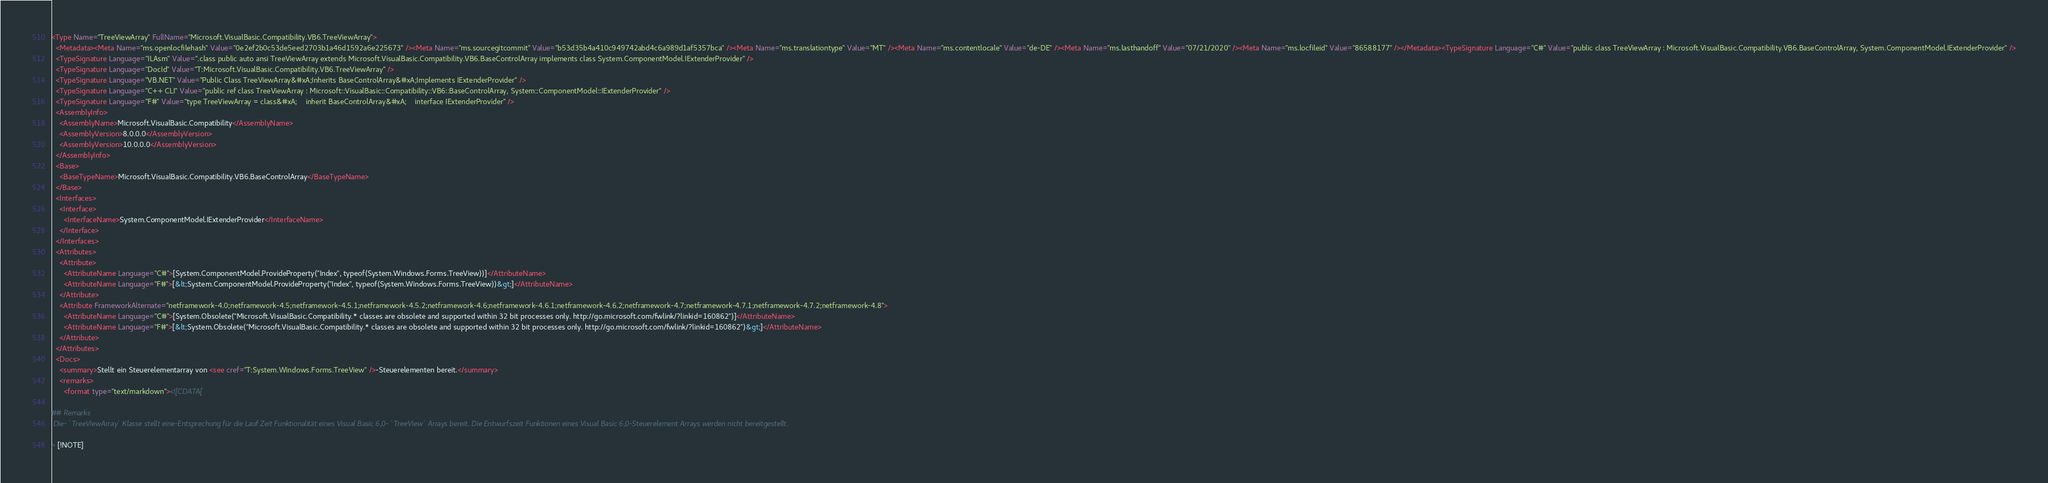Convert code to text. <code><loc_0><loc_0><loc_500><loc_500><_XML_><Type Name="TreeViewArray" FullName="Microsoft.VisualBasic.Compatibility.VB6.TreeViewArray">
  <Metadata><Meta Name="ms.openlocfilehash" Value="0e2ef2b0c53de5eed2703b1a46d1592a6e225673" /><Meta Name="ms.sourcegitcommit" Value="b53d35b4a410c949742abd4c6a989d1af5357bca" /><Meta Name="ms.translationtype" Value="MT" /><Meta Name="ms.contentlocale" Value="de-DE" /><Meta Name="ms.lasthandoff" Value="07/21/2020" /><Meta Name="ms.locfileid" Value="86588177" /></Metadata><TypeSignature Language="C#" Value="public class TreeViewArray : Microsoft.VisualBasic.Compatibility.VB6.BaseControlArray, System.ComponentModel.IExtenderProvider" />
  <TypeSignature Language="ILAsm" Value=".class public auto ansi TreeViewArray extends Microsoft.VisualBasic.Compatibility.VB6.BaseControlArray implements class System.ComponentModel.IExtenderProvider" />
  <TypeSignature Language="DocId" Value="T:Microsoft.VisualBasic.Compatibility.VB6.TreeViewArray" />
  <TypeSignature Language="VB.NET" Value="Public Class TreeViewArray&#xA;Inherits BaseControlArray&#xA;Implements IExtenderProvider" />
  <TypeSignature Language="C++ CLI" Value="public ref class TreeViewArray : Microsoft::VisualBasic::Compatibility::VB6::BaseControlArray, System::ComponentModel::IExtenderProvider" />
  <TypeSignature Language="F#" Value="type TreeViewArray = class&#xA;    inherit BaseControlArray&#xA;    interface IExtenderProvider" />
  <AssemblyInfo>
    <AssemblyName>Microsoft.VisualBasic.Compatibility</AssemblyName>
    <AssemblyVersion>8.0.0.0</AssemblyVersion>
    <AssemblyVersion>10.0.0.0</AssemblyVersion>
  </AssemblyInfo>
  <Base>
    <BaseTypeName>Microsoft.VisualBasic.Compatibility.VB6.BaseControlArray</BaseTypeName>
  </Base>
  <Interfaces>
    <Interface>
      <InterfaceName>System.ComponentModel.IExtenderProvider</InterfaceName>
    </Interface>
  </Interfaces>
  <Attributes>
    <Attribute>
      <AttributeName Language="C#">[System.ComponentModel.ProvideProperty("Index", typeof(System.Windows.Forms.TreeView))]</AttributeName>
      <AttributeName Language="F#">[&lt;System.ComponentModel.ProvideProperty("Index", typeof(System.Windows.Forms.TreeView))&gt;]</AttributeName>
    </Attribute>
    <Attribute FrameworkAlternate="netframework-4.0;netframework-4.5;netframework-4.5.1;netframework-4.5.2;netframework-4.6;netframework-4.6.1;netframework-4.6.2;netframework-4.7;netframework-4.7.1;netframework-4.7.2;netframework-4.8">
      <AttributeName Language="C#">[System.Obsolete("Microsoft.VisualBasic.Compatibility.* classes are obsolete and supported within 32 bit processes only. http://go.microsoft.com/fwlink/?linkid=160862")]</AttributeName>
      <AttributeName Language="F#">[&lt;System.Obsolete("Microsoft.VisualBasic.Compatibility.* classes are obsolete and supported within 32 bit processes only. http://go.microsoft.com/fwlink/?linkid=160862")&gt;]</AttributeName>
    </Attribute>
  </Attributes>
  <Docs>
    <summary>Stellt ein Steuerelementarray von <see cref="T:System.Windows.Forms.TreeView" />-Steuerelementen bereit.</summary>
    <remarks>
      <format type="text/markdown"><![CDATA[  
  
## Remarks  
 Die- `TreeViewArray` Klasse stellt eine-Entsprechung für die Lauf Zeit Funktionalität eines Visual Basic 6,0- `TreeView` Arrays bereit. Die Entwurfszeit Funktionen eines Visual Basic 6,0-Steuerelement Arrays werden nicht bereitgestellt.  
  
> [!NOTE]</code> 